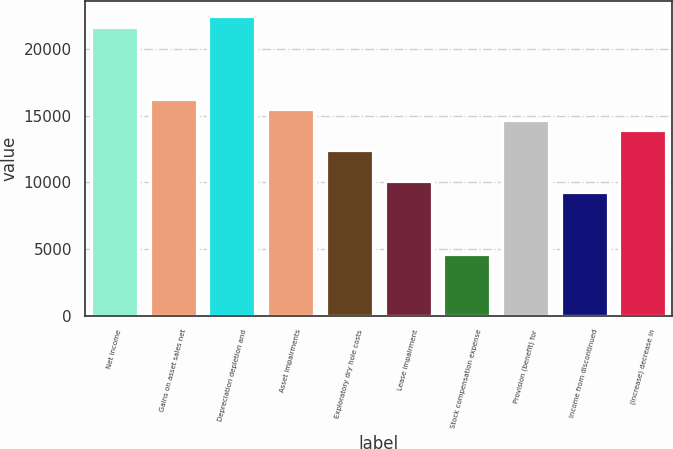<chart> <loc_0><loc_0><loc_500><loc_500><bar_chart><fcel>Net income<fcel>Gains on asset sales net<fcel>Depreciation depletion and<fcel>Asset impairments<fcel>Exploratory dry hole costs<fcel>Lease impairment<fcel>Stock compensation expense<fcel>Provision (benefit) for<fcel>Income from discontinued<fcel>(Increase) decrease in<nl><fcel>21678.6<fcel>16259.2<fcel>22452.8<fcel>15485<fcel>12388.2<fcel>10065.6<fcel>4646.2<fcel>14710.8<fcel>9291.4<fcel>13936.6<nl></chart> 